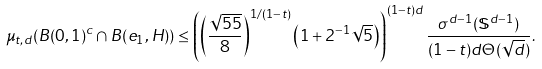<formula> <loc_0><loc_0><loc_500><loc_500>\mu _ { t , d } ( B ( 0 , 1 ) ^ { c } \cap B ( e _ { 1 } , H ) ) \leq \left ( \left ( \frac { \sqrt { 5 5 } } { 8 } \right ) ^ { 1 / ( 1 - t ) } \left ( 1 + 2 ^ { - 1 } \sqrt { 5 } \right ) \right ) ^ { ( 1 - t ) d } \frac { \sigma ^ { d - 1 } ( \mathbb { S } ^ { d - 1 } ) } { ( 1 - t ) d \Theta ( \sqrt { d } ) } .</formula> 